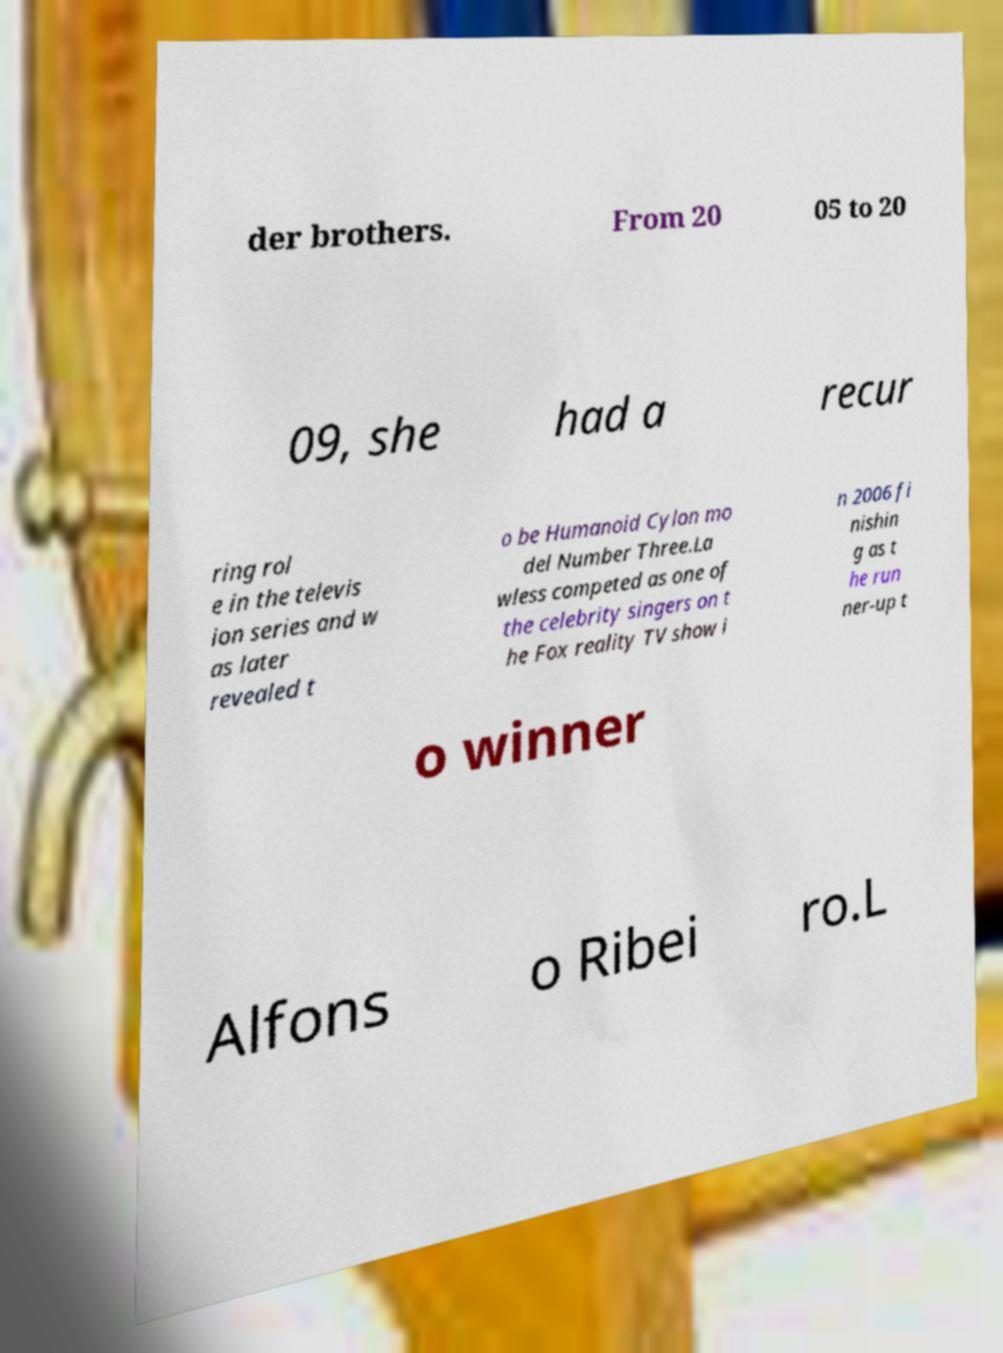For documentation purposes, I need the text within this image transcribed. Could you provide that? der brothers. From 20 05 to 20 09, she had a recur ring rol e in the televis ion series and w as later revealed t o be Humanoid Cylon mo del Number Three.La wless competed as one of the celebrity singers on t he Fox reality TV show i n 2006 fi nishin g as t he run ner-up t o winner Alfons o Ribei ro.L 